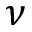Convert formula to latex. <formula><loc_0><loc_0><loc_500><loc_500>\nu</formula> 